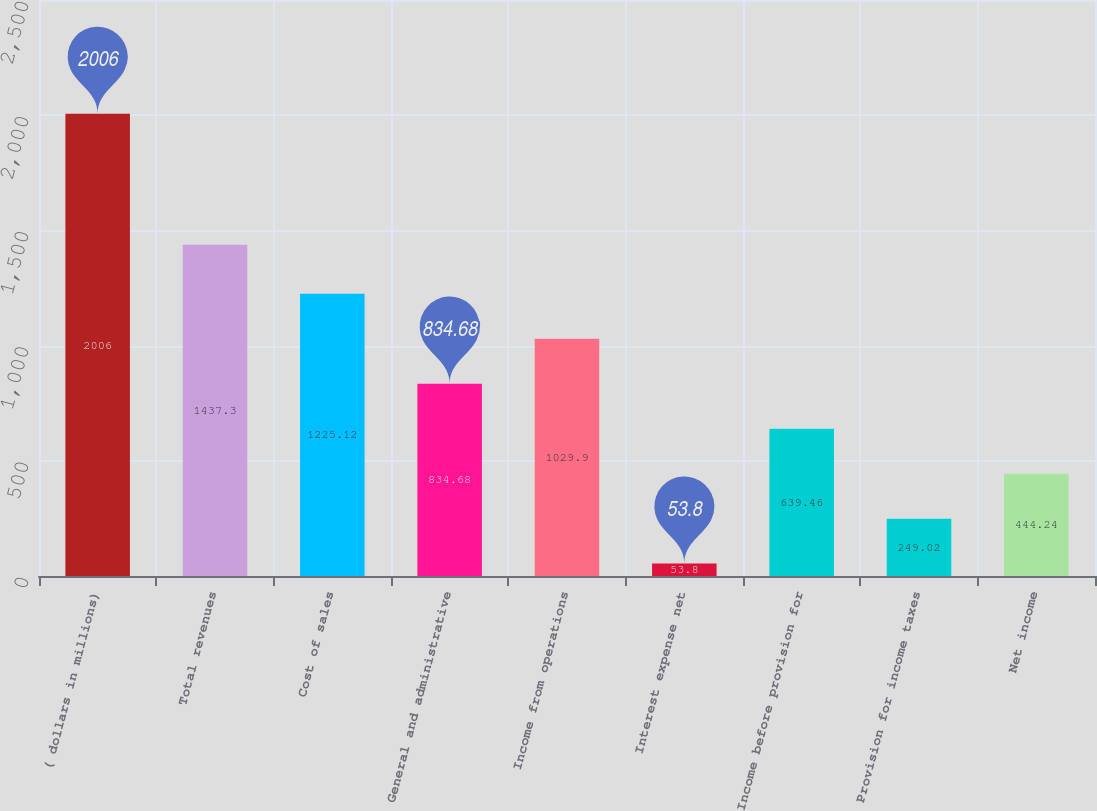Convert chart. <chart><loc_0><loc_0><loc_500><loc_500><bar_chart><fcel>( dollars in millions)<fcel>Total revenues<fcel>Cost of sales<fcel>General and administrative<fcel>Income from operations<fcel>Interest expense net<fcel>Income before provision for<fcel>Provision for income taxes<fcel>Net income<nl><fcel>2006<fcel>1437.3<fcel>1225.12<fcel>834.68<fcel>1029.9<fcel>53.8<fcel>639.46<fcel>249.02<fcel>444.24<nl></chart> 